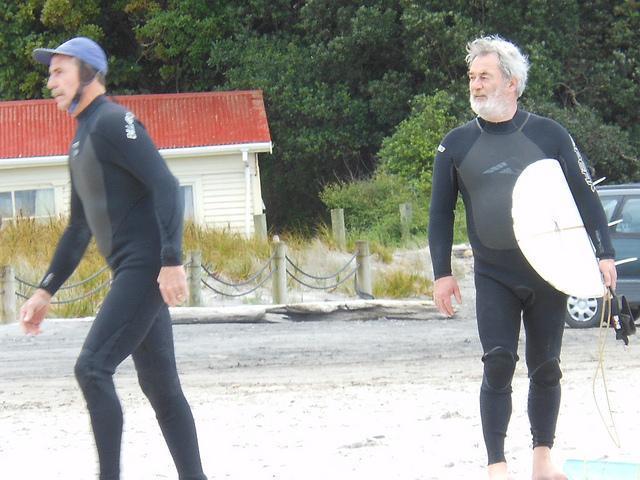Where do these men want to go next?
Answer the question by selecting the correct answer among the 4 following choices.
Options: Cafe, bed, home, ocean. Ocean. Why are there two oval patterns on the right man's pants?
Pick the correct solution from the four options below to address the question.
Options: Fashion, broken, knee protection, dress code. Knee protection. 